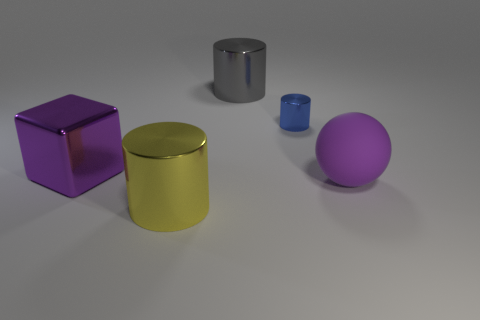There is a big purple thing right of the purple thing on the left side of the big gray shiny object; what is its material?
Offer a terse response. Rubber. Is the size of the purple matte thing the same as the purple metal cube?
Your response must be concise. Yes. How many small things are either cyan matte cubes or yellow objects?
Offer a terse response. 0. How many cylinders are behind the big purple metal block?
Your answer should be compact. 2. Is the number of tiny cylinders that are to the right of the big purple sphere greater than the number of blue metal objects?
Your answer should be compact. No. What is the shape of the big yellow object that is the same material as the small blue cylinder?
Make the answer very short. Cylinder. There is a big metallic object in front of the large thing that is to the left of the large yellow object; what is its color?
Give a very brief answer. Yellow. Does the gray thing have the same shape as the blue metallic thing?
Offer a very short reply. Yes. There is a big cylinder to the right of the large object that is in front of the big rubber sphere; is there a yellow object in front of it?
Provide a short and direct response. Yes. Do the yellow metallic object and the big metallic thing to the right of the yellow cylinder have the same shape?
Offer a terse response. Yes. 